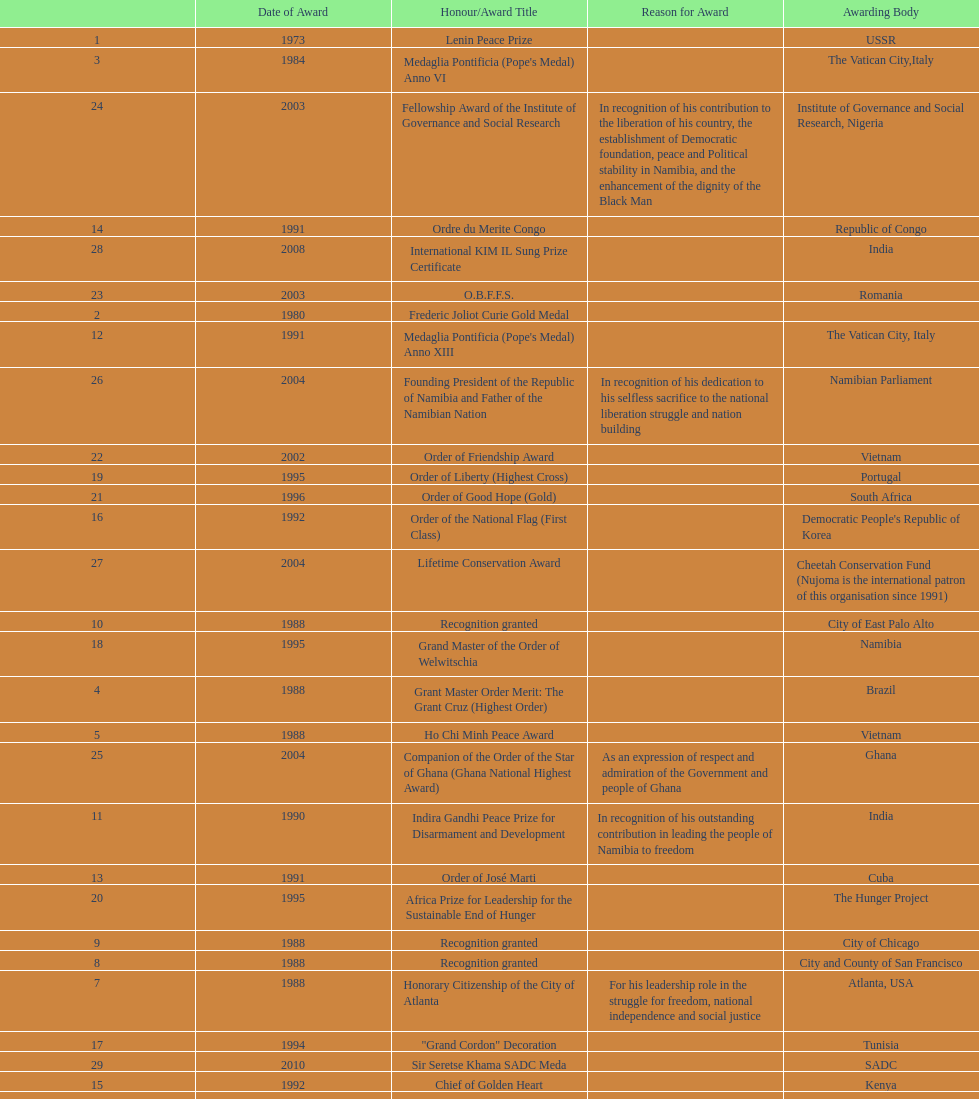What were the total number of honors/award titles listed according to this chart? 29. 